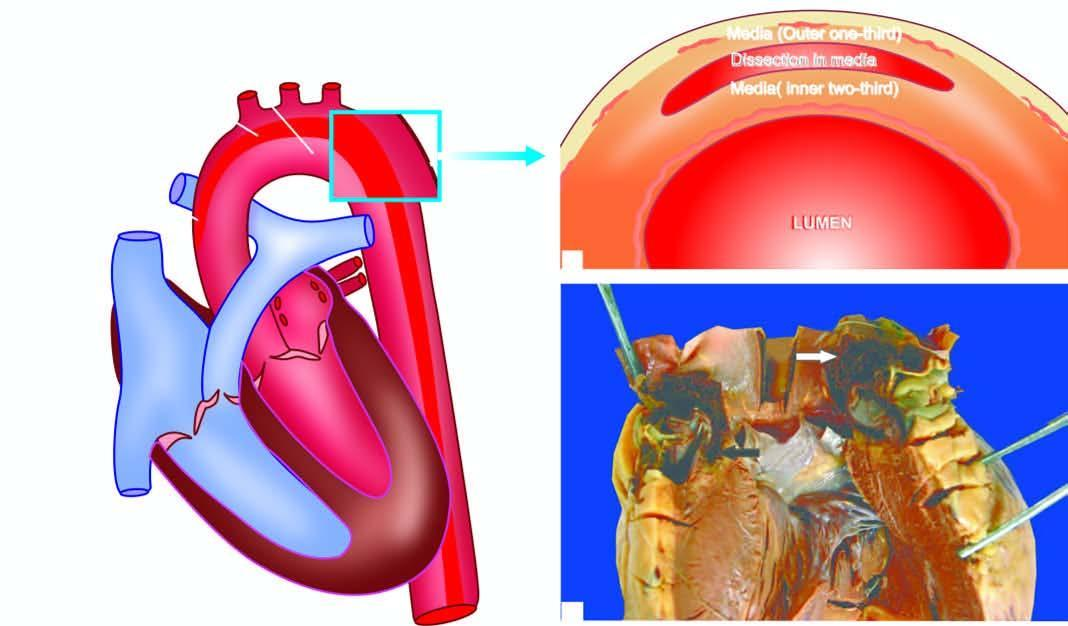what tear in the aortic wall extend proximally upto aortic valve dissecting the media which contains clotted blood?
Answer the question using a single word or phrase. An intimal 